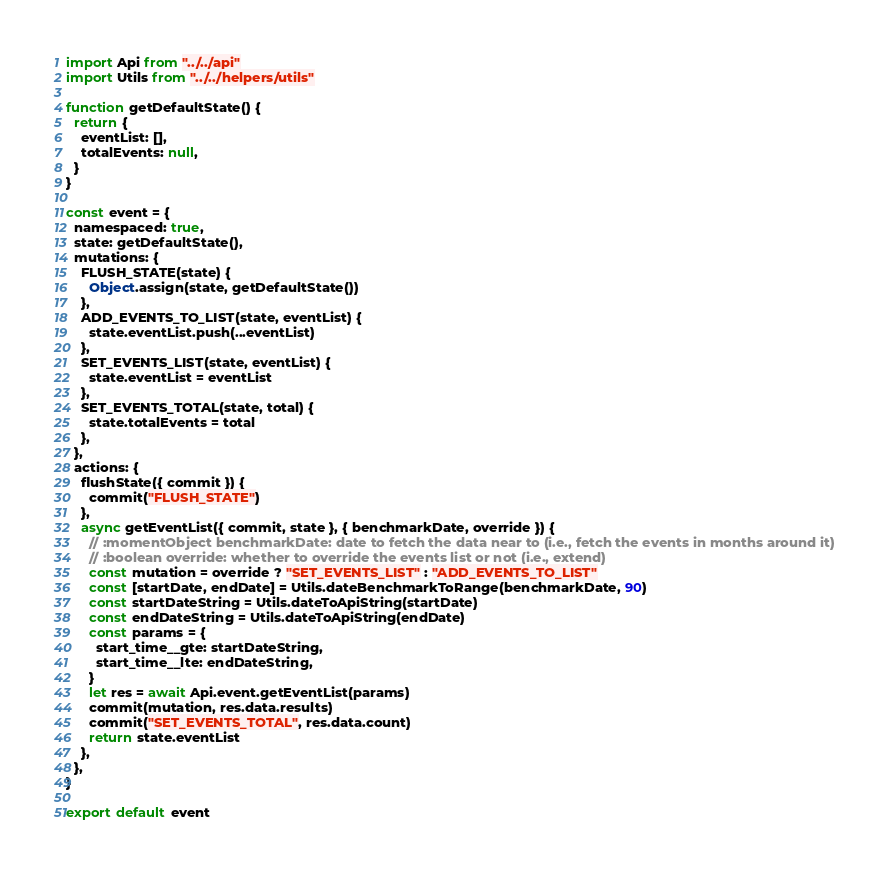Convert code to text. <code><loc_0><loc_0><loc_500><loc_500><_JavaScript_>import Api from "../../api"
import Utils from "../../helpers/utils"

function getDefaultState() {
  return {
    eventList: [],
    totalEvents: null,
  }
}

const event = {
  namespaced: true,
  state: getDefaultState(),
  mutations: {
    FLUSH_STATE(state) {
      Object.assign(state, getDefaultState())
    },
    ADD_EVENTS_TO_LIST(state, eventList) {
      state.eventList.push(...eventList)
    },
    SET_EVENTS_LIST(state, eventList) {
      state.eventList = eventList
    },
    SET_EVENTS_TOTAL(state, total) {
      state.totalEvents = total
    },
  },
  actions: {
    flushState({ commit }) {
      commit("FLUSH_STATE")
    },
    async getEventList({ commit, state }, { benchmarkDate, override }) {
      // :momentObject benchmarkDate: date to fetch the data near to (i.e., fetch the events in months around it)
      // :boolean override: whether to override the events list or not (i.e., extend)
      const mutation = override ? "SET_EVENTS_LIST" : "ADD_EVENTS_TO_LIST"
      const [startDate, endDate] = Utils.dateBenchmarkToRange(benchmarkDate, 90)
      const startDateString = Utils.dateToApiString(startDate)
      const endDateString = Utils.dateToApiString(endDate)
      const params = {
        start_time__gte: startDateString,
        start_time__lte: endDateString,
      }
      let res = await Api.event.getEventList(params)
      commit(mutation, res.data.results)
      commit("SET_EVENTS_TOTAL", res.data.count)
      return state.eventList
    },
  },
}

export default event
</code> 